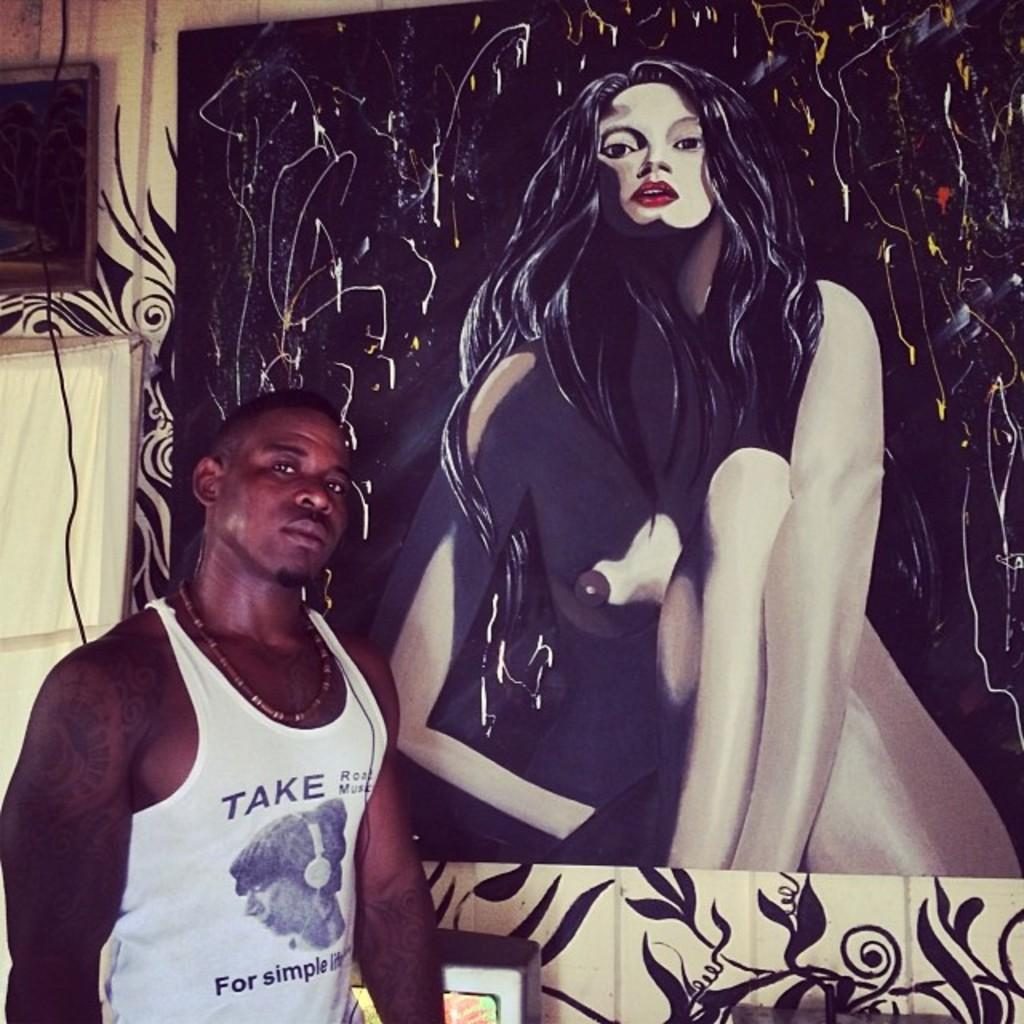<image>
Offer a succinct explanation of the picture presented. Man wearing a tanktop which says TAKE standing next to a painting. 